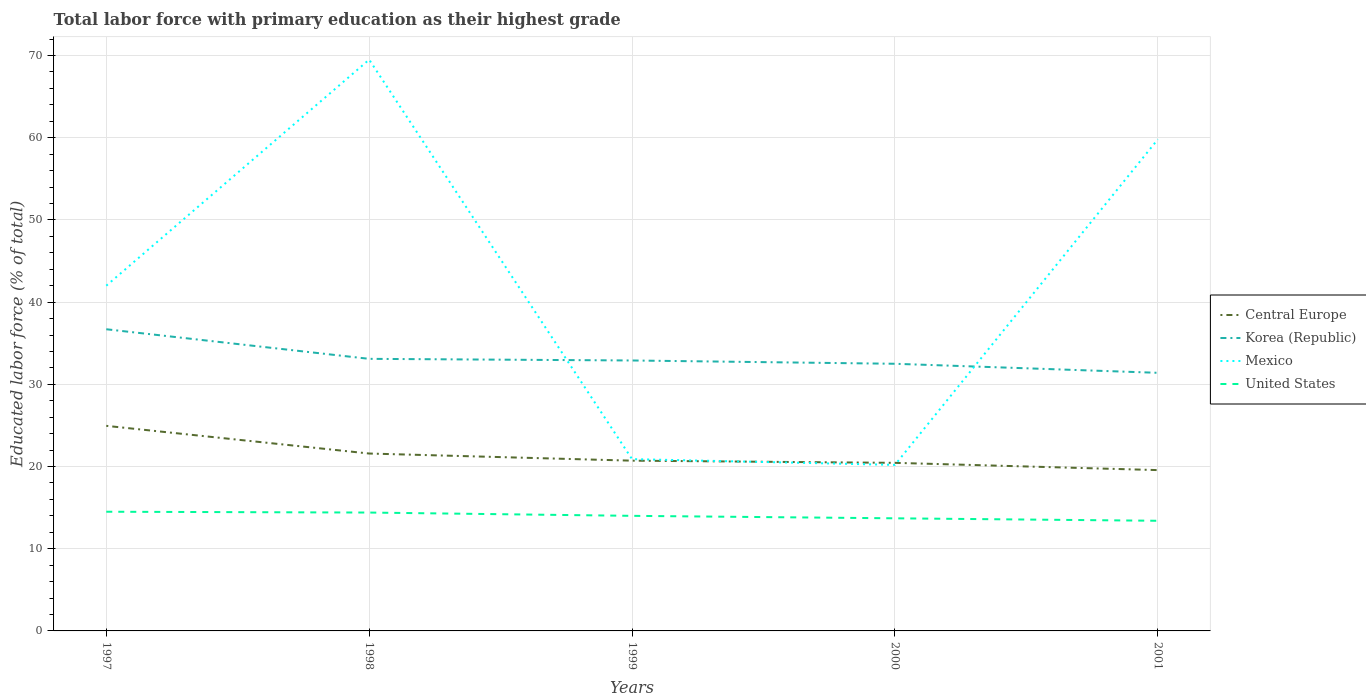How many different coloured lines are there?
Keep it short and to the point. 4. Does the line corresponding to United States intersect with the line corresponding to Mexico?
Make the answer very short. No. Is the number of lines equal to the number of legend labels?
Give a very brief answer. Yes. Across all years, what is the maximum percentage of total labor force with primary education in Central Europe?
Offer a very short reply. 19.56. In which year was the percentage of total labor force with primary education in Korea (Republic) maximum?
Keep it short and to the point. 2001. What is the total percentage of total labor force with primary education in Mexico in the graph?
Ensure brevity in your answer.  0.7. What is the difference between the highest and the second highest percentage of total labor force with primary education in United States?
Provide a short and direct response. 1.1. What is the difference between the highest and the lowest percentage of total labor force with primary education in Mexico?
Provide a short and direct response. 2. Is the percentage of total labor force with primary education in Mexico strictly greater than the percentage of total labor force with primary education in Central Europe over the years?
Offer a terse response. No. How many lines are there?
Your response must be concise. 4. Does the graph contain any zero values?
Offer a very short reply. No. Where does the legend appear in the graph?
Your response must be concise. Center right. What is the title of the graph?
Give a very brief answer. Total labor force with primary education as their highest grade. What is the label or title of the Y-axis?
Provide a short and direct response. Educated labor force (% of total). What is the Educated labor force (% of total) in Central Europe in 1997?
Make the answer very short. 24.95. What is the Educated labor force (% of total) of Korea (Republic) in 1997?
Your answer should be compact. 36.7. What is the Educated labor force (% of total) in Mexico in 1997?
Offer a terse response. 42. What is the Educated labor force (% of total) of United States in 1997?
Make the answer very short. 14.5. What is the Educated labor force (% of total) of Central Europe in 1998?
Give a very brief answer. 21.58. What is the Educated labor force (% of total) in Korea (Republic) in 1998?
Give a very brief answer. 33.1. What is the Educated labor force (% of total) of Mexico in 1998?
Make the answer very short. 69.5. What is the Educated labor force (% of total) in United States in 1998?
Keep it short and to the point. 14.4. What is the Educated labor force (% of total) in Central Europe in 1999?
Your response must be concise. 20.71. What is the Educated labor force (% of total) in Korea (Republic) in 1999?
Provide a succinct answer. 32.9. What is the Educated labor force (% of total) of Mexico in 1999?
Provide a short and direct response. 20.9. What is the Educated labor force (% of total) of United States in 1999?
Provide a short and direct response. 14. What is the Educated labor force (% of total) of Central Europe in 2000?
Provide a succinct answer. 20.45. What is the Educated labor force (% of total) in Korea (Republic) in 2000?
Ensure brevity in your answer.  32.5. What is the Educated labor force (% of total) of Mexico in 2000?
Provide a succinct answer. 20.2. What is the Educated labor force (% of total) in United States in 2000?
Keep it short and to the point. 13.7. What is the Educated labor force (% of total) in Central Europe in 2001?
Offer a very short reply. 19.56. What is the Educated labor force (% of total) in Korea (Republic) in 2001?
Keep it short and to the point. 31.4. What is the Educated labor force (% of total) in Mexico in 2001?
Provide a succinct answer. 59.8. What is the Educated labor force (% of total) in United States in 2001?
Provide a short and direct response. 13.4. Across all years, what is the maximum Educated labor force (% of total) in Central Europe?
Your answer should be very brief. 24.95. Across all years, what is the maximum Educated labor force (% of total) in Korea (Republic)?
Give a very brief answer. 36.7. Across all years, what is the maximum Educated labor force (% of total) of Mexico?
Keep it short and to the point. 69.5. Across all years, what is the maximum Educated labor force (% of total) in United States?
Offer a terse response. 14.5. Across all years, what is the minimum Educated labor force (% of total) of Central Europe?
Keep it short and to the point. 19.56. Across all years, what is the minimum Educated labor force (% of total) of Korea (Republic)?
Provide a short and direct response. 31.4. Across all years, what is the minimum Educated labor force (% of total) of Mexico?
Provide a succinct answer. 20.2. Across all years, what is the minimum Educated labor force (% of total) in United States?
Provide a succinct answer. 13.4. What is the total Educated labor force (% of total) of Central Europe in the graph?
Your answer should be very brief. 107.25. What is the total Educated labor force (% of total) of Korea (Republic) in the graph?
Your answer should be compact. 166.6. What is the total Educated labor force (% of total) of Mexico in the graph?
Offer a very short reply. 212.4. What is the difference between the Educated labor force (% of total) in Central Europe in 1997 and that in 1998?
Offer a terse response. 3.37. What is the difference between the Educated labor force (% of total) of Korea (Republic) in 1997 and that in 1998?
Keep it short and to the point. 3.6. What is the difference between the Educated labor force (% of total) in Mexico in 1997 and that in 1998?
Your response must be concise. -27.5. What is the difference between the Educated labor force (% of total) in Central Europe in 1997 and that in 1999?
Your response must be concise. 4.24. What is the difference between the Educated labor force (% of total) of Mexico in 1997 and that in 1999?
Keep it short and to the point. 21.1. What is the difference between the Educated labor force (% of total) of Central Europe in 1997 and that in 2000?
Give a very brief answer. 4.5. What is the difference between the Educated labor force (% of total) of Mexico in 1997 and that in 2000?
Your response must be concise. 21.8. What is the difference between the Educated labor force (% of total) of United States in 1997 and that in 2000?
Provide a succinct answer. 0.8. What is the difference between the Educated labor force (% of total) of Central Europe in 1997 and that in 2001?
Your answer should be compact. 5.38. What is the difference between the Educated labor force (% of total) of Mexico in 1997 and that in 2001?
Ensure brevity in your answer.  -17.8. What is the difference between the Educated labor force (% of total) of Central Europe in 1998 and that in 1999?
Offer a very short reply. 0.87. What is the difference between the Educated labor force (% of total) in Mexico in 1998 and that in 1999?
Offer a terse response. 48.6. What is the difference between the Educated labor force (% of total) of Central Europe in 1998 and that in 2000?
Offer a very short reply. 1.13. What is the difference between the Educated labor force (% of total) in Korea (Republic) in 1998 and that in 2000?
Give a very brief answer. 0.6. What is the difference between the Educated labor force (% of total) in Mexico in 1998 and that in 2000?
Make the answer very short. 49.3. What is the difference between the Educated labor force (% of total) in Central Europe in 1998 and that in 2001?
Ensure brevity in your answer.  2.02. What is the difference between the Educated labor force (% of total) of Korea (Republic) in 1998 and that in 2001?
Offer a terse response. 1.7. What is the difference between the Educated labor force (% of total) of United States in 1998 and that in 2001?
Offer a very short reply. 1. What is the difference between the Educated labor force (% of total) of Central Europe in 1999 and that in 2000?
Offer a terse response. 0.26. What is the difference between the Educated labor force (% of total) in Mexico in 1999 and that in 2000?
Provide a succinct answer. 0.7. What is the difference between the Educated labor force (% of total) in United States in 1999 and that in 2000?
Keep it short and to the point. 0.3. What is the difference between the Educated labor force (% of total) in Central Europe in 1999 and that in 2001?
Offer a very short reply. 1.15. What is the difference between the Educated labor force (% of total) of Mexico in 1999 and that in 2001?
Your response must be concise. -38.9. What is the difference between the Educated labor force (% of total) in Central Europe in 2000 and that in 2001?
Your answer should be very brief. 0.88. What is the difference between the Educated labor force (% of total) in Mexico in 2000 and that in 2001?
Your answer should be very brief. -39.6. What is the difference between the Educated labor force (% of total) of Central Europe in 1997 and the Educated labor force (% of total) of Korea (Republic) in 1998?
Your response must be concise. -8.15. What is the difference between the Educated labor force (% of total) in Central Europe in 1997 and the Educated labor force (% of total) in Mexico in 1998?
Offer a very short reply. -44.55. What is the difference between the Educated labor force (% of total) in Central Europe in 1997 and the Educated labor force (% of total) in United States in 1998?
Offer a very short reply. 10.55. What is the difference between the Educated labor force (% of total) of Korea (Republic) in 1997 and the Educated labor force (% of total) of Mexico in 1998?
Ensure brevity in your answer.  -32.8. What is the difference between the Educated labor force (% of total) of Korea (Republic) in 1997 and the Educated labor force (% of total) of United States in 1998?
Keep it short and to the point. 22.3. What is the difference between the Educated labor force (% of total) in Mexico in 1997 and the Educated labor force (% of total) in United States in 1998?
Provide a short and direct response. 27.6. What is the difference between the Educated labor force (% of total) in Central Europe in 1997 and the Educated labor force (% of total) in Korea (Republic) in 1999?
Offer a very short reply. -7.95. What is the difference between the Educated labor force (% of total) of Central Europe in 1997 and the Educated labor force (% of total) of Mexico in 1999?
Provide a succinct answer. 4.05. What is the difference between the Educated labor force (% of total) in Central Europe in 1997 and the Educated labor force (% of total) in United States in 1999?
Provide a short and direct response. 10.95. What is the difference between the Educated labor force (% of total) of Korea (Republic) in 1997 and the Educated labor force (% of total) of United States in 1999?
Keep it short and to the point. 22.7. What is the difference between the Educated labor force (% of total) of Central Europe in 1997 and the Educated labor force (% of total) of Korea (Republic) in 2000?
Provide a short and direct response. -7.55. What is the difference between the Educated labor force (% of total) in Central Europe in 1997 and the Educated labor force (% of total) in Mexico in 2000?
Keep it short and to the point. 4.75. What is the difference between the Educated labor force (% of total) in Central Europe in 1997 and the Educated labor force (% of total) in United States in 2000?
Your answer should be very brief. 11.25. What is the difference between the Educated labor force (% of total) of Mexico in 1997 and the Educated labor force (% of total) of United States in 2000?
Keep it short and to the point. 28.3. What is the difference between the Educated labor force (% of total) of Central Europe in 1997 and the Educated labor force (% of total) of Korea (Republic) in 2001?
Give a very brief answer. -6.45. What is the difference between the Educated labor force (% of total) in Central Europe in 1997 and the Educated labor force (% of total) in Mexico in 2001?
Ensure brevity in your answer.  -34.85. What is the difference between the Educated labor force (% of total) of Central Europe in 1997 and the Educated labor force (% of total) of United States in 2001?
Offer a terse response. 11.55. What is the difference between the Educated labor force (% of total) of Korea (Republic) in 1997 and the Educated labor force (% of total) of Mexico in 2001?
Make the answer very short. -23.1. What is the difference between the Educated labor force (% of total) in Korea (Republic) in 1997 and the Educated labor force (% of total) in United States in 2001?
Your response must be concise. 23.3. What is the difference between the Educated labor force (% of total) in Mexico in 1997 and the Educated labor force (% of total) in United States in 2001?
Provide a short and direct response. 28.6. What is the difference between the Educated labor force (% of total) of Central Europe in 1998 and the Educated labor force (% of total) of Korea (Republic) in 1999?
Your answer should be very brief. -11.32. What is the difference between the Educated labor force (% of total) in Central Europe in 1998 and the Educated labor force (% of total) in Mexico in 1999?
Ensure brevity in your answer.  0.68. What is the difference between the Educated labor force (% of total) of Central Europe in 1998 and the Educated labor force (% of total) of United States in 1999?
Provide a short and direct response. 7.58. What is the difference between the Educated labor force (% of total) of Korea (Republic) in 1998 and the Educated labor force (% of total) of United States in 1999?
Your answer should be compact. 19.1. What is the difference between the Educated labor force (% of total) of Mexico in 1998 and the Educated labor force (% of total) of United States in 1999?
Your response must be concise. 55.5. What is the difference between the Educated labor force (% of total) of Central Europe in 1998 and the Educated labor force (% of total) of Korea (Republic) in 2000?
Your response must be concise. -10.92. What is the difference between the Educated labor force (% of total) of Central Europe in 1998 and the Educated labor force (% of total) of Mexico in 2000?
Make the answer very short. 1.38. What is the difference between the Educated labor force (% of total) of Central Europe in 1998 and the Educated labor force (% of total) of United States in 2000?
Keep it short and to the point. 7.88. What is the difference between the Educated labor force (% of total) in Korea (Republic) in 1998 and the Educated labor force (% of total) in United States in 2000?
Ensure brevity in your answer.  19.4. What is the difference between the Educated labor force (% of total) in Mexico in 1998 and the Educated labor force (% of total) in United States in 2000?
Give a very brief answer. 55.8. What is the difference between the Educated labor force (% of total) of Central Europe in 1998 and the Educated labor force (% of total) of Korea (Republic) in 2001?
Make the answer very short. -9.82. What is the difference between the Educated labor force (% of total) in Central Europe in 1998 and the Educated labor force (% of total) in Mexico in 2001?
Make the answer very short. -38.22. What is the difference between the Educated labor force (% of total) in Central Europe in 1998 and the Educated labor force (% of total) in United States in 2001?
Make the answer very short. 8.18. What is the difference between the Educated labor force (% of total) in Korea (Republic) in 1998 and the Educated labor force (% of total) in Mexico in 2001?
Offer a very short reply. -26.7. What is the difference between the Educated labor force (% of total) of Korea (Republic) in 1998 and the Educated labor force (% of total) of United States in 2001?
Ensure brevity in your answer.  19.7. What is the difference between the Educated labor force (% of total) in Mexico in 1998 and the Educated labor force (% of total) in United States in 2001?
Provide a succinct answer. 56.1. What is the difference between the Educated labor force (% of total) of Central Europe in 1999 and the Educated labor force (% of total) of Korea (Republic) in 2000?
Ensure brevity in your answer.  -11.79. What is the difference between the Educated labor force (% of total) of Central Europe in 1999 and the Educated labor force (% of total) of Mexico in 2000?
Keep it short and to the point. 0.51. What is the difference between the Educated labor force (% of total) in Central Europe in 1999 and the Educated labor force (% of total) in United States in 2000?
Your answer should be very brief. 7.01. What is the difference between the Educated labor force (% of total) in Korea (Republic) in 1999 and the Educated labor force (% of total) in Mexico in 2000?
Your response must be concise. 12.7. What is the difference between the Educated labor force (% of total) of Central Europe in 1999 and the Educated labor force (% of total) of Korea (Republic) in 2001?
Your response must be concise. -10.69. What is the difference between the Educated labor force (% of total) of Central Europe in 1999 and the Educated labor force (% of total) of Mexico in 2001?
Your answer should be compact. -39.09. What is the difference between the Educated labor force (% of total) in Central Europe in 1999 and the Educated labor force (% of total) in United States in 2001?
Ensure brevity in your answer.  7.31. What is the difference between the Educated labor force (% of total) in Korea (Republic) in 1999 and the Educated labor force (% of total) in Mexico in 2001?
Your answer should be compact. -26.9. What is the difference between the Educated labor force (% of total) in Korea (Republic) in 1999 and the Educated labor force (% of total) in United States in 2001?
Provide a succinct answer. 19.5. What is the difference between the Educated labor force (% of total) of Mexico in 1999 and the Educated labor force (% of total) of United States in 2001?
Your answer should be very brief. 7.5. What is the difference between the Educated labor force (% of total) of Central Europe in 2000 and the Educated labor force (% of total) of Korea (Republic) in 2001?
Keep it short and to the point. -10.95. What is the difference between the Educated labor force (% of total) in Central Europe in 2000 and the Educated labor force (% of total) in Mexico in 2001?
Offer a very short reply. -39.35. What is the difference between the Educated labor force (% of total) of Central Europe in 2000 and the Educated labor force (% of total) of United States in 2001?
Your answer should be compact. 7.05. What is the difference between the Educated labor force (% of total) in Korea (Republic) in 2000 and the Educated labor force (% of total) in Mexico in 2001?
Offer a very short reply. -27.3. What is the difference between the Educated labor force (% of total) of Mexico in 2000 and the Educated labor force (% of total) of United States in 2001?
Make the answer very short. 6.8. What is the average Educated labor force (% of total) of Central Europe per year?
Ensure brevity in your answer.  21.45. What is the average Educated labor force (% of total) in Korea (Republic) per year?
Give a very brief answer. 33.32. What is the average Educated labor force (% of total) of Mexico per year?
Offer a terse response. 42.48. In the year 1997, what is the difference between the Educated labor force (% of total) of Central Europe and Educated labor force (% of total) of Korea (Republic)?
Make the answer very short. -11.75. In the year 1997, what is the difference between the Educated labor force (% of total) of Central Europe and Educated labor force (% of total) of Mexico?
Your answer should be compact. -17.05. In the year 1997, what is the difference between the Educated labor force (% of total) in Central Europe and Educated labor force (% of total) in United States?
Keep it short and to the point. 10.45. In the year 1998, what is the difference between the Educated labor force (% of total) in Central Europe and Educated labor force (% of total) in Korea (Republic)?
Your answer should be compact. -11.52. In the year 1998, what is the difference between the Educated labor force (% of total) in Central Europe and Educated labor force (% of total) in Mexico?
Make the answer very short. -47.92. In the year 1998, what is the difference between the Educated labor force (% of total) of Central Europe and Educated labor force (% of total) of United States?
Your response must be concise. 7.18. In the year 1998, what is the difference between the Educated labor force (% of total) in Korea (Republic) and Educated labor force (% of total) in Mexico?
Offer a terse response. -36.4. In the year 1998, what is the difference between the Educated labor force (% of total) in Mexico and Educated labor force (% of total) in United States?
Offer a very short reply. 55.1. In the year 1999, what is the difference between the Educated labor force (% of total) in Central Europe and Educated labor force (% of total) in Korea (Republic)?
Give a very brief answer. -12.19. In the year 1999, what is the difference between the Educated labor force (% of total) in Central Europe and Educated labor force (% of total) in Mexico?
Offer a terse response. -0.19. In the year 1999, what is the difference between the Educated labor force (% of total) in Central Europe and Educated labor force (% of total) in United States?
Provide a succinct answer. 6.71. In the year 1999, what is the difference between the Educated labor force (% of total) of Korea (Republic) and Educated labor force (% of total) of Mexico?
Offer a very short reply. 12. In the year 1999, what is the difference between the Educated labor force (% of total) in Korea (Republic) and Educated labor force (% of total) in United States?
Keep it short and to the point. 18.9. In the year 2000, what is the difference between the Educated labor force (% of total) of Central Europe and Educated labor force (% of total) of Korea (Republic)?
Offer a terse response. -12.05. In the year 2000, what is the difference between the Educated labor force (% of total) in Central Europe and Educated labor force (% of total) in Mexico?
Your response must be concise. 0.25. In the year 2000, what is the difference between the Educated labor force (% of total) in Central Europe and Educated labor force (% of total) in United States?
Your answer should be compact. 6.75. In the year 2000, what is the difference between the Educated labor force (% of total) in Korea (Republic) and Educated labor force (% of total) in Mexico?
Your answer should be compact. 12.3. In the year 2000, what is the difference between the Educated labor force (% of total) of Mexico and Educated labor force (% of total) of United States?
Your answer should be compact. 6.5. In the year 2001, what is the difference between the Educated labor force (% of total) in Central Europe and Educated labor force (% of total) in Korea (Republic)?
Your answer should be very brief. -11.84. In the year 2001, what is the difference between the Educated labor force (% of total) in Central Europe and Educated labor force (% of total) in Mexico?
Offer a terse response. -40.24. In the year 2001, what is the difference between the Educated labor force (% of total) in Central Europe and Educated labor force (% of total) in United States?
Provide a succinct answer. 6.16. In the year 2001, what is the difference between the Educated labor force (% of total) in Korea (Republic) and Educated labor force (% of total) in Mexico?
Offer a terse response. -28.4. In the year 2001, what is the difference between the Educated labor force (% of total) in Korea (Republic) and Educated labor force (% of total) in United States?
Give a very brief answer. 18. In the year 2001, what is the difference between the Educated labor force (% of total) of Mexico and Educated labor force (% of total) of United States?
Keep it short and to the point. 46.4. What is the ratio of the Educated labor force (% of total) in Central Europe in 1997 to that in 1998?
Make the answer very short. 1.16. What is the ratio of the Educated labor force (% of total) in Korea (Republic) in 1997 to that in 1998?
Ensure brevity in your answer.  1.11. What is the ratio of the Educated labor force (% of total) in Mexico in 1997 to that in 1998?
Offer a very short reply. 0.6. What is the ratio of the Educated labor force (% of total) of United States in 1997 to that in 1998?
Provide a succinct answer. 1.01. What is the ratio of the Educated labor force (% of total) of Central Europe in 1997 to that in 1999?
Offer a very short reply. 1.2. What is the ratio of the Educated labor force (% of total) of Korea (Republic) in 1997 to that in 1999?
Make the answer very short. 1.12. What is the ratio of the Educated labor force (% of total) in Mexico in 1997 to that in 1999?
Your answer should be compact. 2.01. What is the ratio of the Educated labor force (% of total) of United States in 1997 to that in 1999?
Your answer should be compact. 1.04. What is the ratio of the Educated labor force (% of total) of Central Europe in 1997 to that in 2000?
Give a very brief answer. 1.22. What is the ratio of the Educated labor force (% of total) in Korea (Republic) in 1997 to that in 2000?
Provide a succinct answer. 1.13. What is the ratio of the Educated labor force (% of total) in Mexico in 1997 to that in 2000?
Provide a succinct answer. 2.08. What is the ratio of the Educated labor force (% of total) of United States in 1997 to that in 2000?
Provide a short and direct response. 1.06. What is the ratio of the Educated labor force (% of total) of Central Europe in 1997 to that in 2001?
Provide a succinct answer. 1.28. What is the ratio of the Educated labor force (% of total) in Korea (Republic) in 1997 to that in 2001?
Keep it short and to the point. 1.17. What is the ratio of the Educated labor force (% of total) of Mexico in 1997 to that in 2001?
Offer a very short reply. 0.7. What is the ratio of the Educated labor force (% of total) in United States in 1997 to that in 2001?
Ensure brevity in your answer.  1.08. What is the ratio of the Educated labor force (% of total) in Central Europe in 1998 to that in 1999?
Keep it short and to the point. 1.04. What is the ratio of the Educated labor force (% of total) in Korea (Republic) in 1998 to that in 1999?
Give a very brief answer. 1.01. What is the ratio of the Educated labor force (% of total) in Mexico in 1998 to that in 1999?
Offer a terse response. 3.33. What is the ratio of the Educated labor force (% of total) of United States in 1998 to that in 1999?
Provide a succinct answer. 1.03. What is the ratio of the Educated labor force (% of total) of Central Europe in 1998 to that in 2000?
Your response must be concise. 1.06. What is the ratio of the Educated labor force (% of total) of Korea (Republic) in 1998 to that in 2000?
Provide a short and direct response. 1.02. What is the ratio of the Educated labor force (% of total) of Mexico in 1998 to that in 2000?
Provide a short and direct response. 3.44. What is the ratio of the Educated labor force (% of total) of United States in 1998 to that in 2000?
Your answer should be compact. 1.05. What is the ratio of the Educated labor force (% of total) in Central Europe in 1998 to that in 2001?
Your answer should be very brief. 1.1. What is the ratio of the Educated labor force (% of total) in Korea (Republic) in 1998 to that in 2001?
Your response must be concise. 1.05. What is the ratio of the Educated labor force (% of total) in Mexico in 1998 to that in 2001?
Ensure brevity in your answer.  1.16. What is the ratio of the Educated labor force (% of total) in United States in 1998 to that in 2001?
Your answer should be compact. 1.07. What is the ratio of the Educated labor force (% of total) of Central Europe in 1999 to that in 2000?
Your answer should be very brief. 1.01. What is the ratio of the Educated labor force (% of total) of Korea (Republic) in 1999 to that in 2000?
Ensure brevity in your answer.  1.01. What is the ratio of the Educated labor force (% of total) of Mexico in 1999 to that in 2000?
Give a very brief answer. 1.03. What is the ratio of the Educated labor force (% of total) in United States in 1999 to that in 2000?
Your answer should be very brief. 1.02. What is the ratio of the Educated labor force (% of total) in Central Europe in 1999 to that in 2001?
Offer a very short reply. 1.06. What is the ratio of the Educated labor force (% of total) of Korea (Republic) in 1999 to that in 2001?
Provide a short and direct response. 1.05. What is the ratio of the Educated labor force (% of total) of Mexico in 1999 to that in 2001?
Your answer should be compact. 0.35. What is the ratio of the Educated labor force (% of total) in United States in 1999 to that in 2001?
Your answer should be very brief. 1.04. What is the ratio of the Educated labor force (% of total) of Central Europe in 2000 to that in 2001?
Your answer should be compact. 1.05. What is the ratio of the Educated labor force (% of total) of Korea (Republic) in 2000 to that in 2001?
Your response must be concise. 1.03. What is the ratio of the Educated labor force (% of total) in Mexico in 2000 to that in 2001?
Your answer should be very brief. 0.34. What is the ratio of the Educated labor force (% of total) of United States in 2000 to that in 2001?
Your answer should be very brief. 1.02. What is the difference between the highest and the second highest Educated labor force (% of total) of Central Europe?
Offer a terse response. 3.37. What is the difference between the highest and the second highest Educated labor force (% of total) of Korea (Republic)?
Your answer should be very brief. 3.6. What is the difference between the highest and the second highest Educated labor force (% of total) of United States?
Your answer should be compact. 0.1. What is the difference between the highest and the lowest Educated labor force (% of total) of Central Europe?
Offer a terse response. 5.38. What is the difference between the highest and the lowest Educated labor force (% of total) of Korea (Republic)?
Keep it short and to the point. 5.3. What is the difference between the highest and the lowest Educated labor force (% of total) in Mexico?
Provide a short and direct response. 49.3. What is the difference between the highest and the lowest Educated labor force (% of total) of United States?
Offer a terse response. 1.1. 